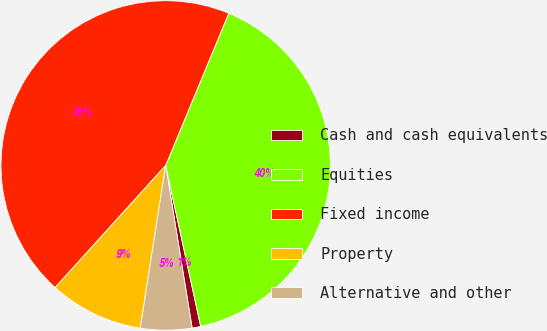Convert chart to OTSL. <chart><loc_0><loc_0><loc_500><loc_500><pie_chart><fcel>Cash and cash equivalents<fcel>Equities<fcel>Fixed income<fcel>Property<fcel>Alternative and other<nl><fcel>0.84%<fcel>40.34%<fcel>44.54%<fcel>9.24%<fcel>5.04%<nl></chart> 